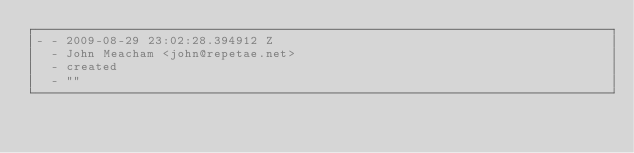<code> <loc_0><loc_0><loc_500><loc_500><_YAML_>- - 2009-08-29 23:02:28.394912 Z
  - John Meacham <john@repetae.net>
  - created
  - ""
</code> 